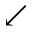Convert formula to latex. <formula><loc_0><loc_0><loc_500><loc_500>\swarrow</formula> 